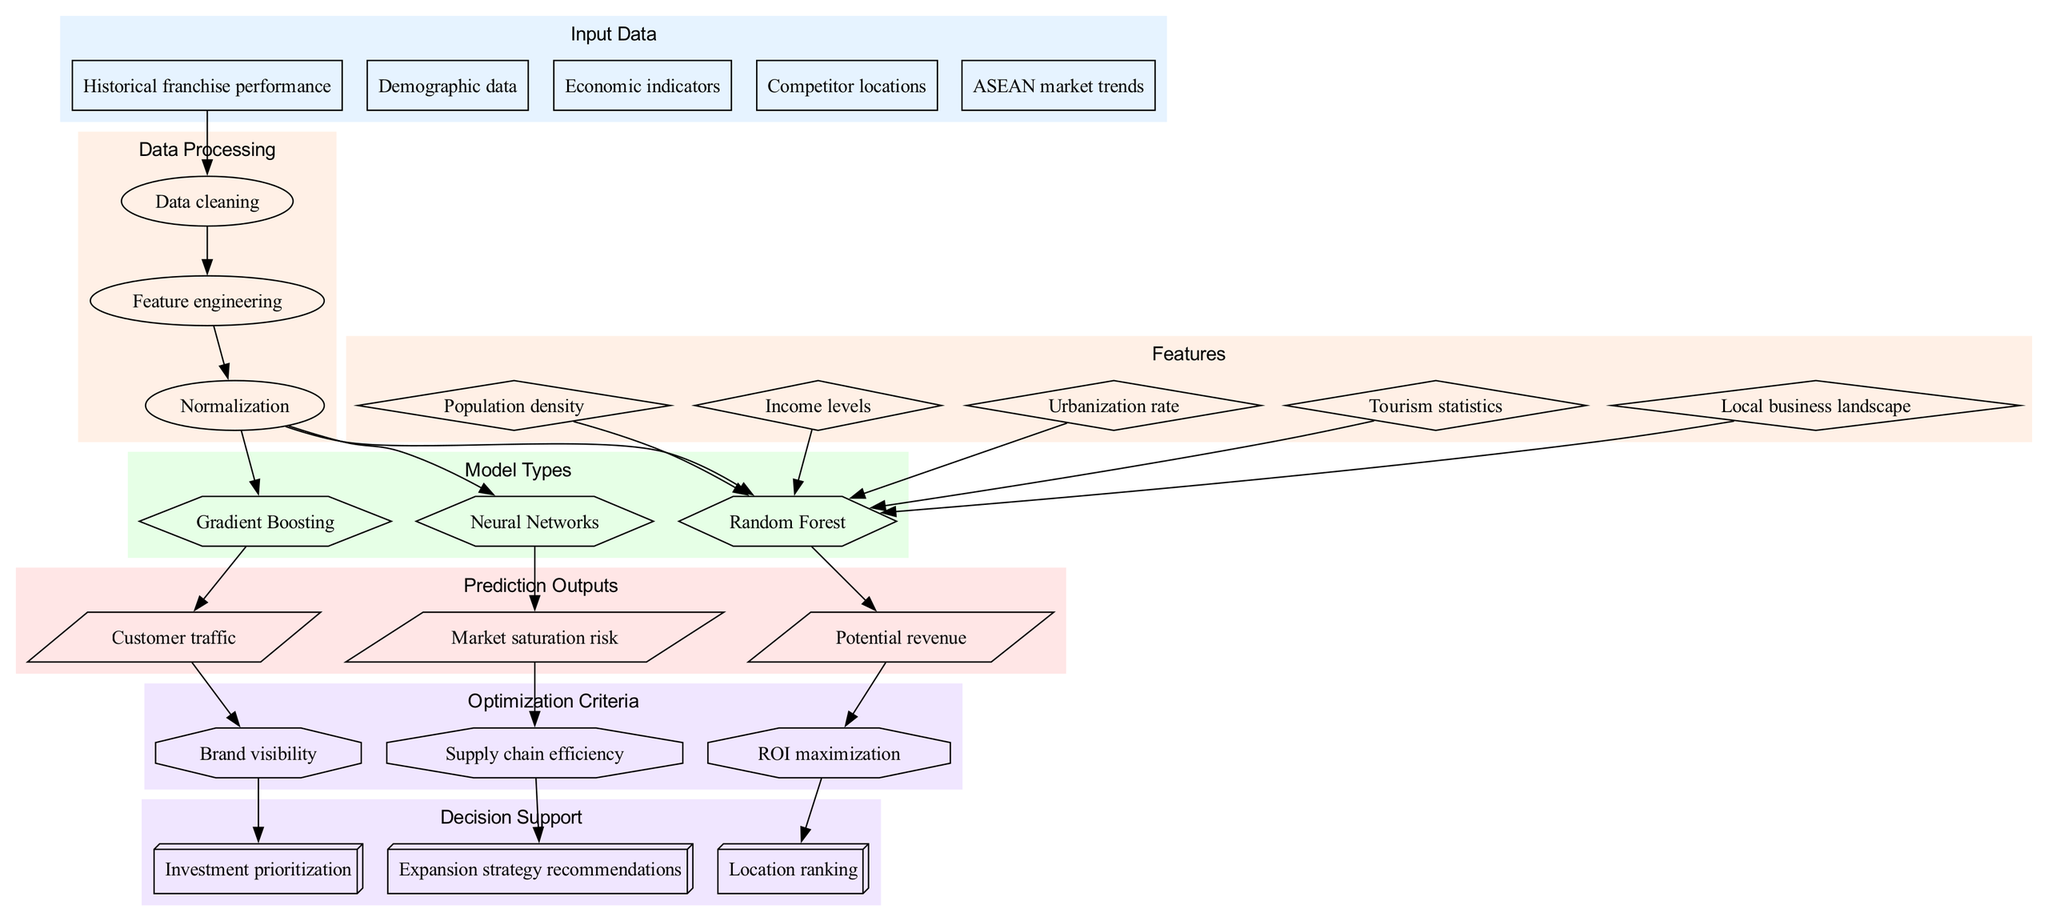What are the different types of input data? The diagram lists five types of input data: Historical franchise performance, Demographic data, Economic indicators, Competitor locations, and ASEAN market trends.
Answer: Historical franchise performance, Demographic data, Economic indicators, Competitor locations, ASEAN market trends How many model types are used in the framework? The diagram displays three model types: Random Forest, Gradient Boosting, and Neural Networks. Counting these gives a total of three model types.
Answer: Three What is the output related to customer traffic? The diagram indicates that the output related to customer traffic is defined as Customer traffic, which is produced by the Gradient Boosting model.
Answer: Customer traffic Which feature influences the Random Forest model? The diagram shows that Population density, Income levels, Urbanization rate, Tourism statistics, and Local business landscape all influence the Random Forest model, highlighted by edges leading to it.
Answer: Population density, Income levels, Urbanization rate, Tourism statistics, Local business landscape Which optimization criterion is derived from potential revenue? The diagram directly connects Potential revenue to the optimization criterion ROI maximization. This indicates that ROI maximization is derived from the potential revenue predictions.
Answer: ROI maximization Which model type predicts market saturation risk? According to the diagram, market saturation risk is predicted by the Neural Networks model, as indicated by the direct edge from Neural Networks to Market saturation risk.
Answer: Neural Networks How many prediction outputs are identified in the diagram? The diagram presents three prediction outputs: Potential revenue, Customer traffic, and Market saturation risk. Counting these outputs shows there are three.
Answer: Three What decision support method is associated with brand visibility? The diagram shows that Brand visibility is connected to the decision support method Investment prioritization, as indicated by the edge going from Brand visibility to Investment prioritization.
Answer: Investment prioritization What processing step follows data cleaning? The diagram indicates that Feature engineering follows the Data cleaning step, represented by the directed edge from Data cleaning to Feature engineering.
Answer: Feature engineering 